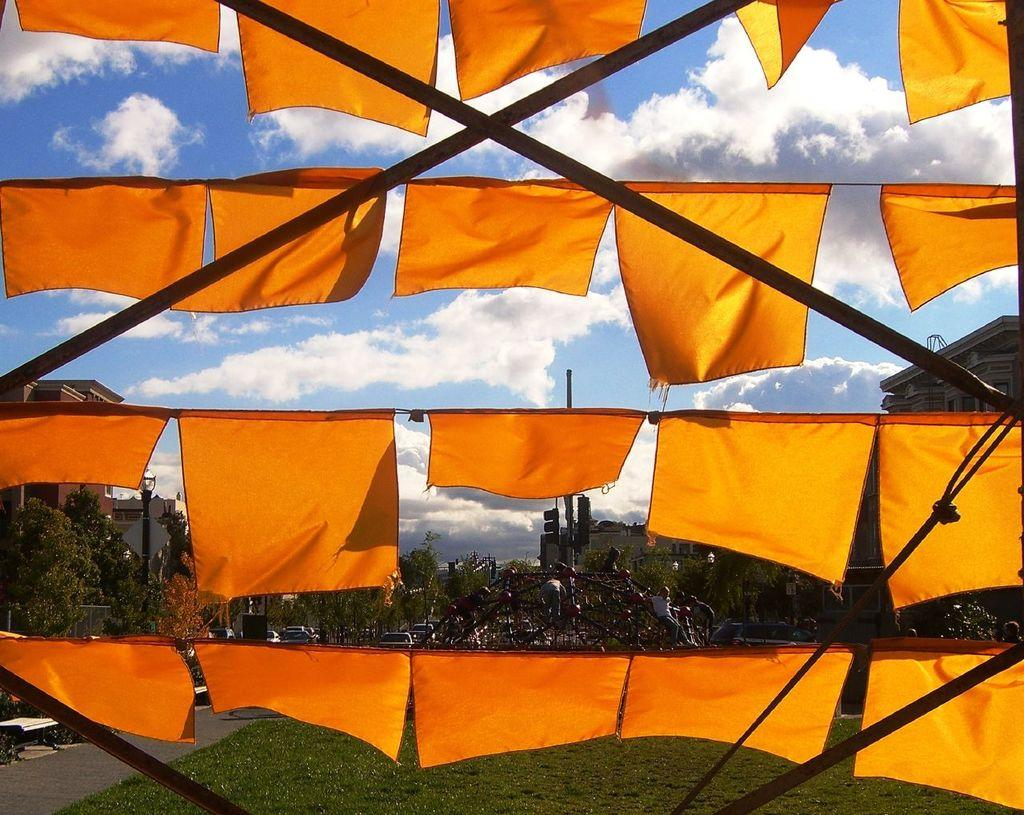What color are the flags in the image? The flags in the image are orange. What type of vegetation is present in the image? There are many trees in the image. What type of structures can be seen in the image? There are buildings in the image. What is visible in the background of the image? The sky is visible in the image, and there are clouds in the sky. What type of ground surface is at the bottom of the image? There is grass at the bottom of the image. Is there a chain attached to the trees in the image? There is no mention of a chain in the image, so we cannot determine if one is present. What type of division is depicted in the image? The image does not show any divisions or separations; it features trees, buildings, flags, sky, clouds, and grass. 